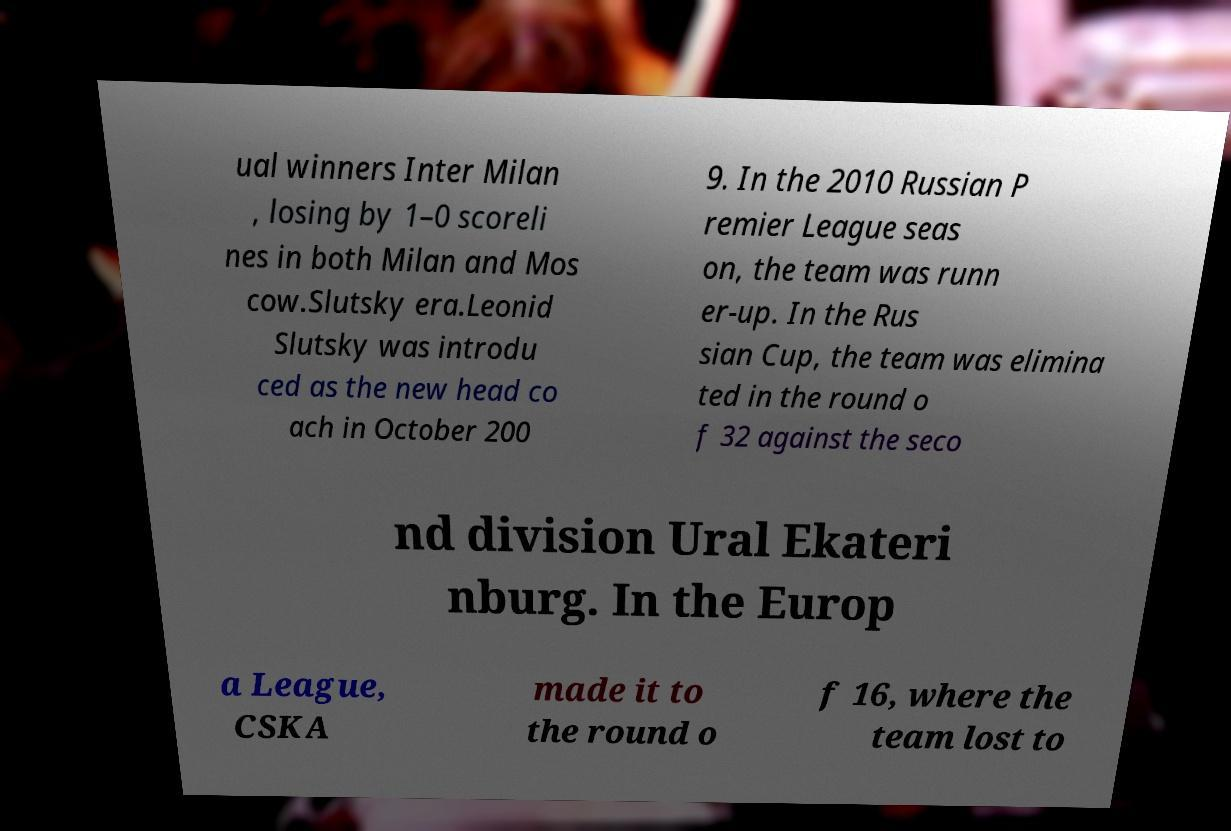Please identify and transcribe the text found in this image. ual winners Inter Milan , losing by 1–0 scoreli nes in both Milan and Mos cow.Slutsky era.Leonid Slutsky was introdu ced as the new head co ach in October 200 9. In the 2010 Russian P remier League seas on, the team was runn er-up. In the Rus sian Cup, the team was elimina ted in the round o f 32 against the seco nd division Ural Ekateri nburg. In the Europ a League, CSKA made it to the round o f 16, where the team lost to 